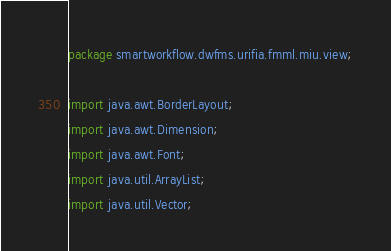Convert code to text. <code><loc_0><loc_0><loc_500><loc_500><_Java_>package smartworkflow.dwfms.urifia.fmml.miu.view;

import java.awt.BorderLayout;
import java.awt.Dimension;
import java.awt.Font;
import java.util.ArrayList;
import java.util.Vector;
</code> 